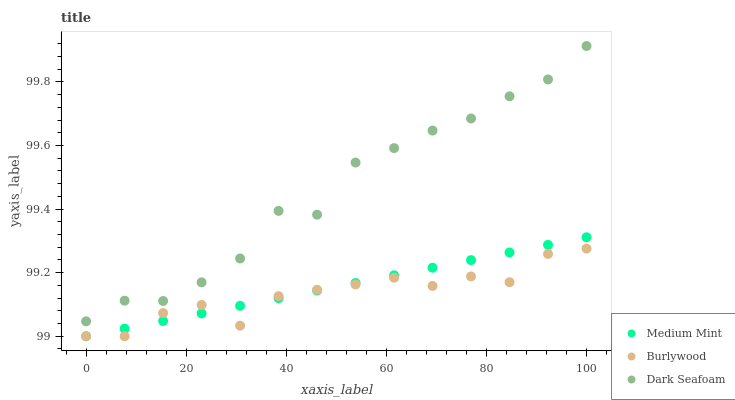Does Burlywood have the minimum area under the curve?
Answer yes or no. Yes. Does Dark Seafoam have the maximum area under the curve?
Answer yes or no. Yes. Does Dark Seafoam have the minimum area under the curve?
Answer yes or no. No. Does Burlywood have the maximum area under the curve?
Answer yes or no. No. Is Medium Mint the smoothest?
Answer yes or no. Yes. Is Dark Seafoam the roughest?
Answer yes or no. Yes. Is Burlywood the smoothest?
Answer yes or no. No. Is Burlywood the roughest?
Answer yes or no. No. Does Medium Mint have the lowest value?
Answer yes or no. Yes. Does Dark Seafoam have the lowest value?
Answer yes or no. No. Does Dark Seafoam have the highest value?
Answer yes or no. Yes. Does Burlywood have the highest value?
Answer yes or no. No. Is Burlywood less than Dark Seafoam?
Answer yes or no. Yes. Is Dark Seafoam greater than Burlywood?
Answer yes or no. Yes. Does Medium Mint intersect Burlywood?
Answer yes or no. Yes. Is Medium Mint less than Burlywood?
Answer yes or no. No. Is Medium Mint greater than Burlywood?
Answer yes or no. No. Does Burlywood intersect Dark Seafoam?
Answer yes or no. No. 